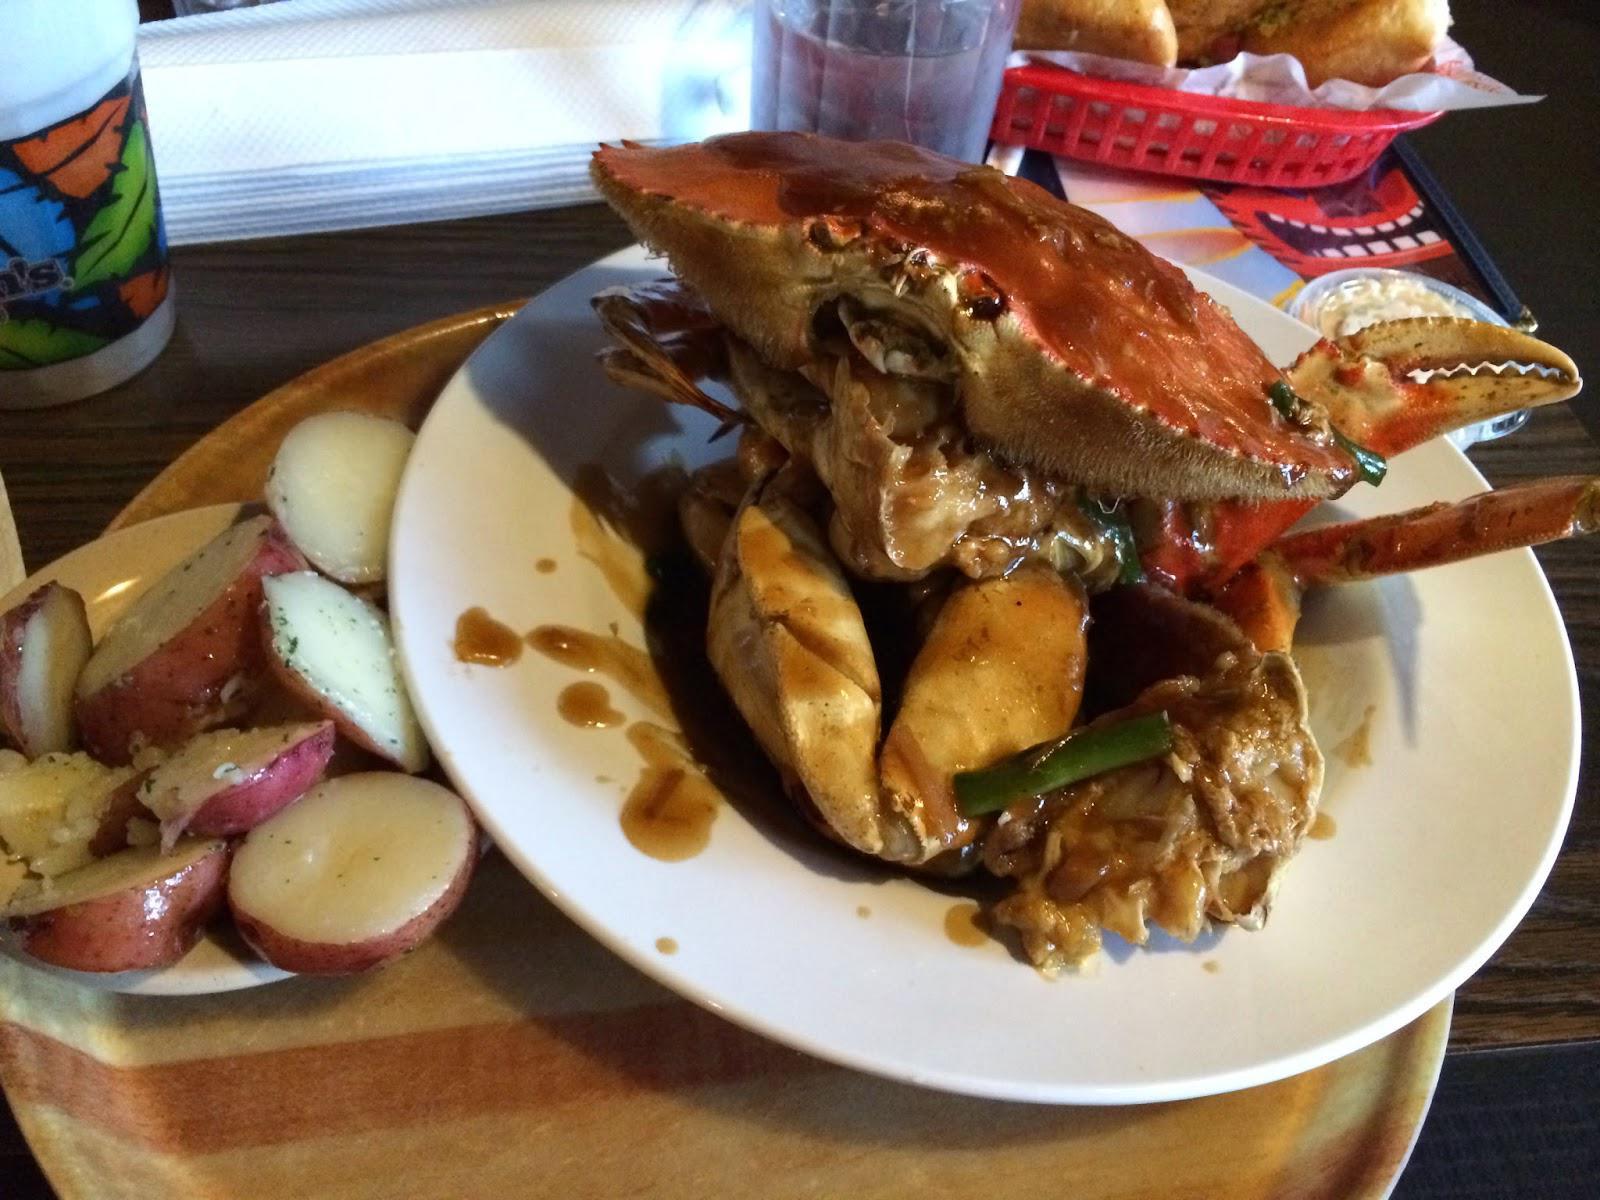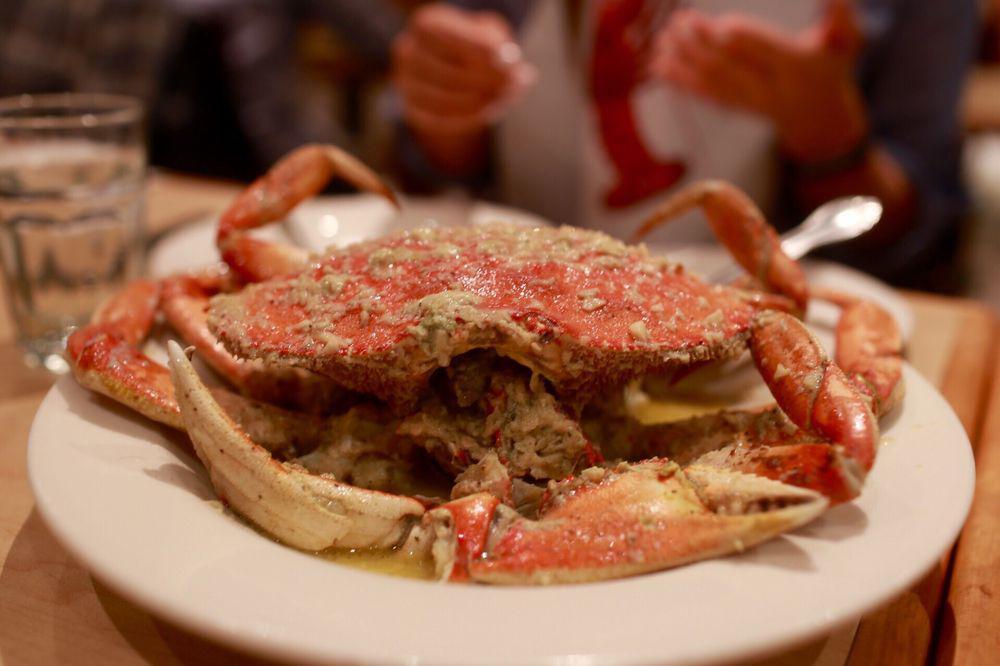The first image is the image on the left, the second image is the image on the right. Examine the images to the left and right. Is the description "Each image contains exactly one round white plate that contains crab [and no other plates containing crab]." accurate? Answer yes or no. Yes. The first image is the image on the left, the second image is the image on the right. For the images shown, is this caption "There are two cooked crabs on a plate." true? Answer yes or no. No. 